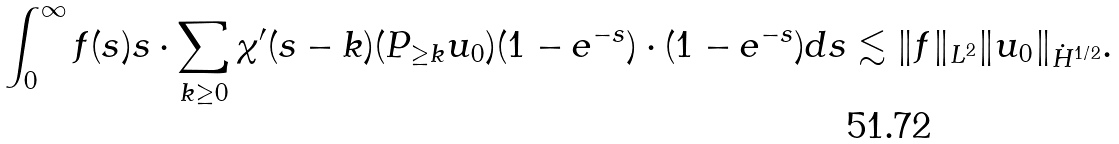Convert formula to latex. <formula><loc_0><loc_0><loc_500><loc_500>\int _ { 0 } ^ { \infty } f ( s ) s \cdot \sum _ { k \geq 0 } \chi ^ { \prime } ( s - k ) ( P _ { \geq k } u _ { 0 } ) ( 1 - e ^ { - s } ) \cdot ( 1 - e ^ { - s } ) d s \lesssim \| f \| _ { L ^ { 2 } } \| u _ { 0 } \| _ { \dot { H } ^ { 1 / 2 } } .</formula> 